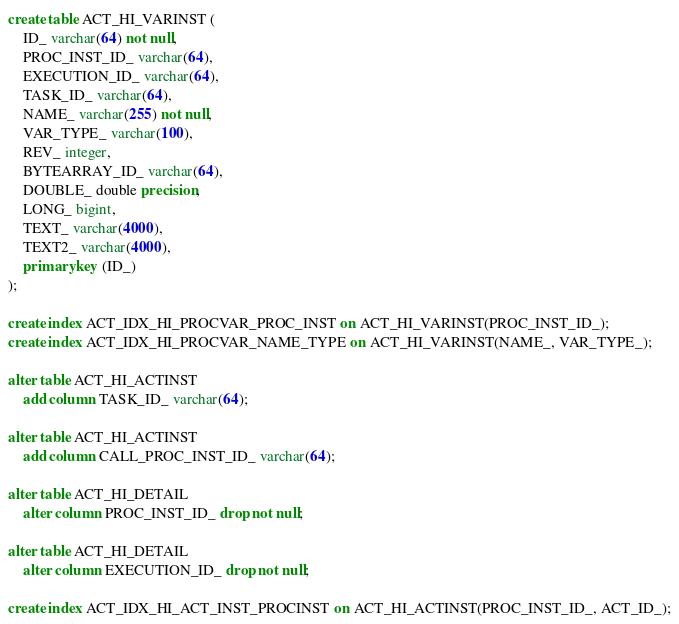<code> <loc_0><loc_0><loc_500><loc_500><_SQL_>create table ACT_HI_VARINST (
    ID_ varchar(64) not null,
    PROC_INST_ID_ varchar(64),
    EXECUTION_ID_ varchar(64),
    TASK_ID_ varchar(64),
    NAME_ varchar(255) not null,
    VAR_TYPE_ varchar(100),
    REV_ integer,
    BYTEARRAY_ID_ varchar(64),
    DOUBLE_ double precision,
    LONG_ bigint,
    TEXT_ varchar(4000),
    TEXT2_ varchar(4000),
    primary key (ID_)
);

create index ACT_IDX_HI_PROCVAR_PROC_INST on ACT_HI_VARINST(PROC_INST_ID_);
create index ACT_IDX_HI_PROCVAR_NAME_TYPE on ACT_HI_VARINST(NAME_, VAR_TYPE_);

alter table ACT_HI_ACTINST
	add column TASK_ID_ varchar(64);

alter table ACT_HI_ACTINST
	add column CALL_PROC_INST_ID_ varchar(64);

alter table ACT_HI_DETAIL
	alter column PROC_INST_ID_ drop not null;

alter table ACT_HI_DETAIL
	alter column EXECUTION_ID_ drop not null;

create index ACT_IDX_HI_ACT_INST_PROCINST on ACT_HI_ACTINST(PROC_INST_ID_, ACT_ID_);
</code> 